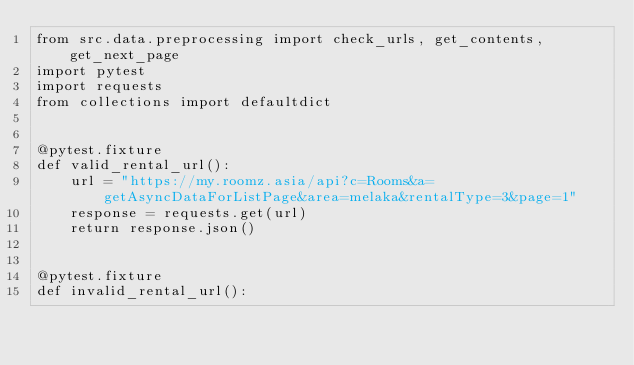Convert code to text. <code><loc_0><loc_0><loc_500><loc_500><_Python_>from src.data.preprocessing import check_urls, get_contents, get_next_page
import pytest
import requests
from collections import defaultdict


@pytest.fixture
def valid_rental_url():
    url = "https://my.roomz.asia/api?c=Rooms&a=getAsyncDataForListPage&area=melaka&rentalType=3&page=1"
    response = requests.get(url)
    return response.json()


@pytest.fixture
def invalid_rental_url():</code> 